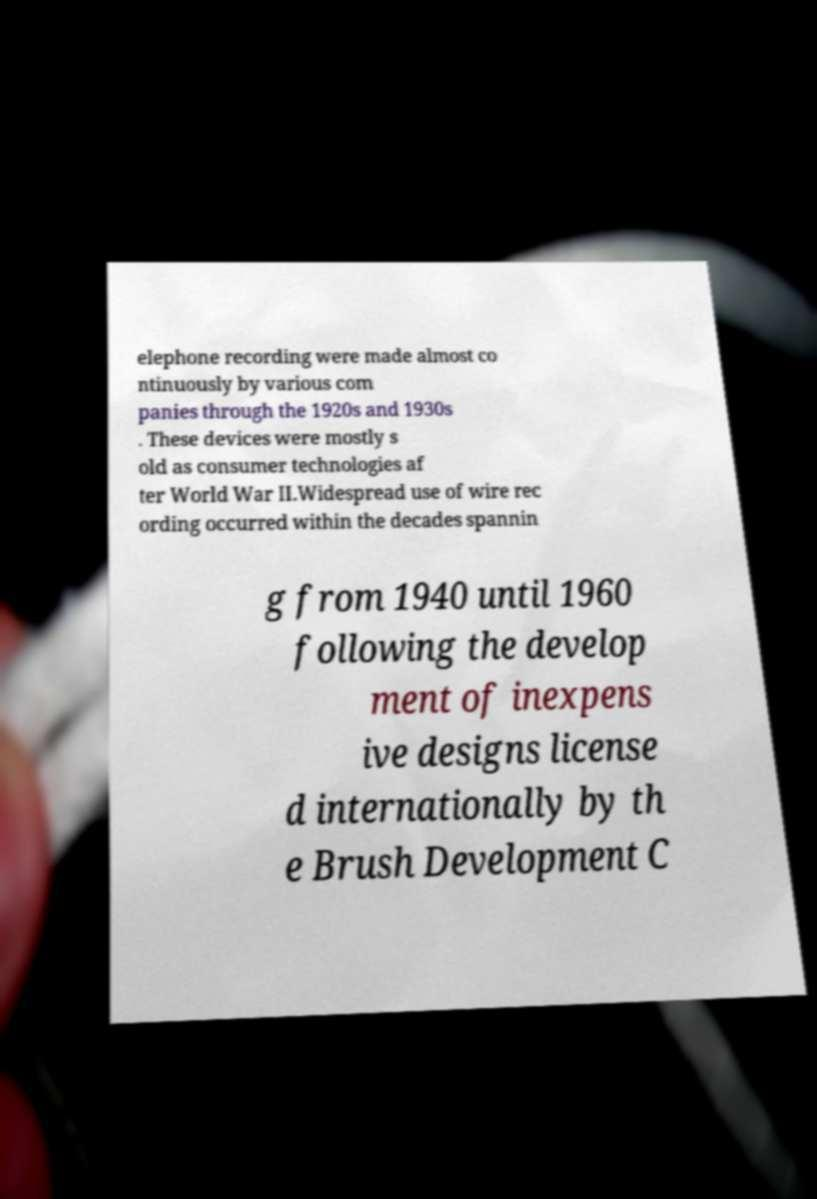Please identify and transcribe the text found in this image. elephone recording were made almost co ntinuously by various com panies through the 1920s and 1930s . These devices were mostly s old as consumer technologies af ter World War II.Widespread use of wire rec ording occurred within the decades spannin g from 1940 until 1960 following the develop ment of inexpens ive designs license d internationally by th e Brush Development C 